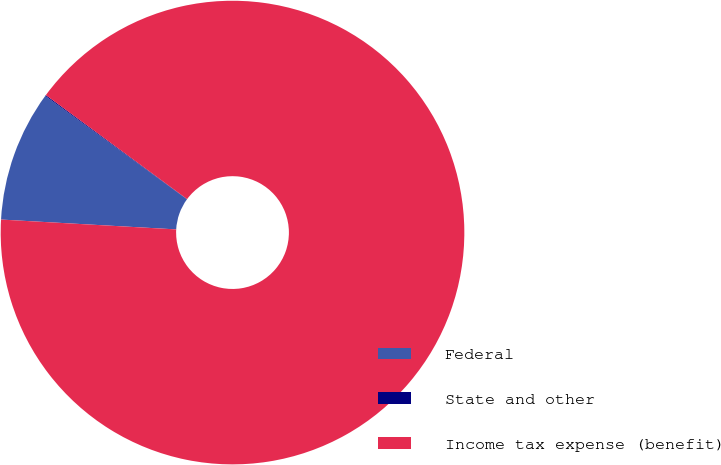Convert chart. <chart><loc_0><loc_0><loc_500><loc_500><pie_chart><fcel>Federal<fcel>State and other<fcel>Income tax expense (benefit)<nl><fcel>9.14%<fcel>0.07%<fcel>90.79%<nl></chart> 